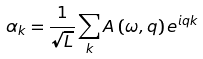<formula> <loc_0><loc_0><loc_500><loc_500>\alpha _ { k } = \frac { 1 } { \sqrt { L } } \sum _ { k } A \left ( \omega , q \right ) e ^ { i q k }</formula> 